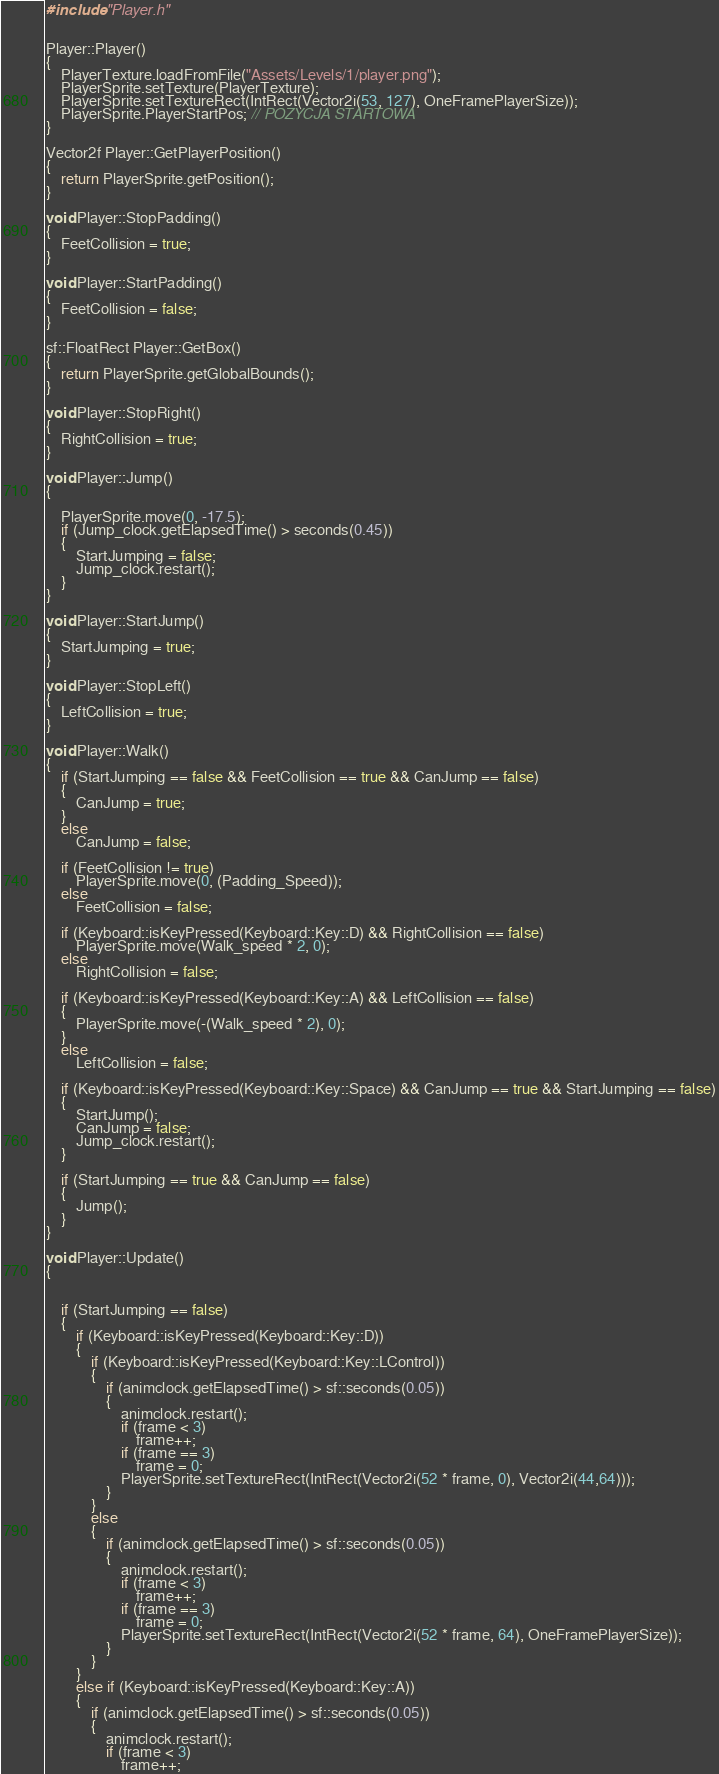Convert code to text. <code><loc_0><loc_0><loc_500><loc_500><_C++_>#include "Player.h"


Player::Player()
{
	PlayerTexture.loadFromFile("Assets/Levels/1/player.png");
	PlayerSprite.setTexture(PlayerTexture);
	PlayerSprite.setTextureRect(IntRect(Vector2i(53, 127), OneFramePlayerSize));
	PlayerSprite.PlayerStartPos; // POZYCJA STARTOWA
}

Vector2f Player::GetPlayerPosition()
{
	return PlayerSprite.getPosition();
}

void Player::StopPadding()
{
	FeetCollision = true;
}

void Player::StartPadding()
{
	FeetCollision = false;
}

sf::FloatRect Player::GetBox()
{
	return PlayerSprite.getGlobalBounds();
}

void Player::StopRight()
{
	RightCollision = true;
}

void Player::Jump()
{

	PlayerSprite.move(0, -17.5);
	if (Jump_clock.getElapsedTime() > seconds(0.45))
	{
		StartJumping = false;
		Jump_clock.restart();
	}
}

void Player::StartJump()
{
	StartJumping = true;
}

void Player::StopLeft()
{
	LeftCollision = true;
}

void Player::Walk()
{
	if (StartJumping == false && FeetCollision == true && CanJump == false)
	{
		CanJump = true;
	}
	else
		CanJump = false;

	if (FeetCollision != true)
		PlayerSprite.move(0, (Padding_Speed));
	else
		FeetCollision = false;

	if (Keyboard::isKeyPressed(Keyboard::Key::D) && RightCollision == false)
		PlayerSprite.move(Walk_speed * 2, 0);
	else
		RightCollision = false;

	if (Keyboard::isKeyPressed(Keyboard::Key::A) && LeftCollision == false)
	{
		PlayerSprite.move(-(Walk_speed * 2), 0);
	}
	else
		LeftCollision = false;

	if (Keyboard::isKeyPressed(Keyboard::Key::Space) && CanJump == true && StartJumping == false)
	{
		StartJump();
		CanJump = false;
		Jump_clock.restart();
	}

	if (StartJumping == true && CanJump == false)
	{
		Jump();
	}
}

void Player::Update()
{


	if (StartJumping == false)
	{
		if (Keyboard::isKeyPressed(Keyboard::Key::D))
		{
			if (Keyboard::isKeyPressed(Keyboard::Key::LControl))
			{
				if (animclock.getElapsedTime() > sf::seconds(0.05))
				{
					animclock.restart();
					if (frame < 3)
						frame++;
					if (frame == 3)
						frame = 0;
					PlayerSprite.setTextureRect(IntRect(Vector2i(52 * frame, 0), Vector2i(44,64)));
				}
			}
			else
			{
				if (animclock.getElapsedTime() > sf::seconds(0.05))
				{
					animclock.restart();
					if (frame < 3)
						frame++;
					if (frame == 3)
						frame = 0;
					PlayerSprite.setTextureRect(IntRect(Vector2i(52 * frame, 64), OneFramePlayerSize));
				}
			}
		}
		else if (Keyboard::isKeyPressed(Keyboard::Key::A))
		{
			if (animclock.getElapsedTime() > sf::seconds(0.05))
			{
				animclock.restart();
				if (frame < 3)
					frame++;</code> 